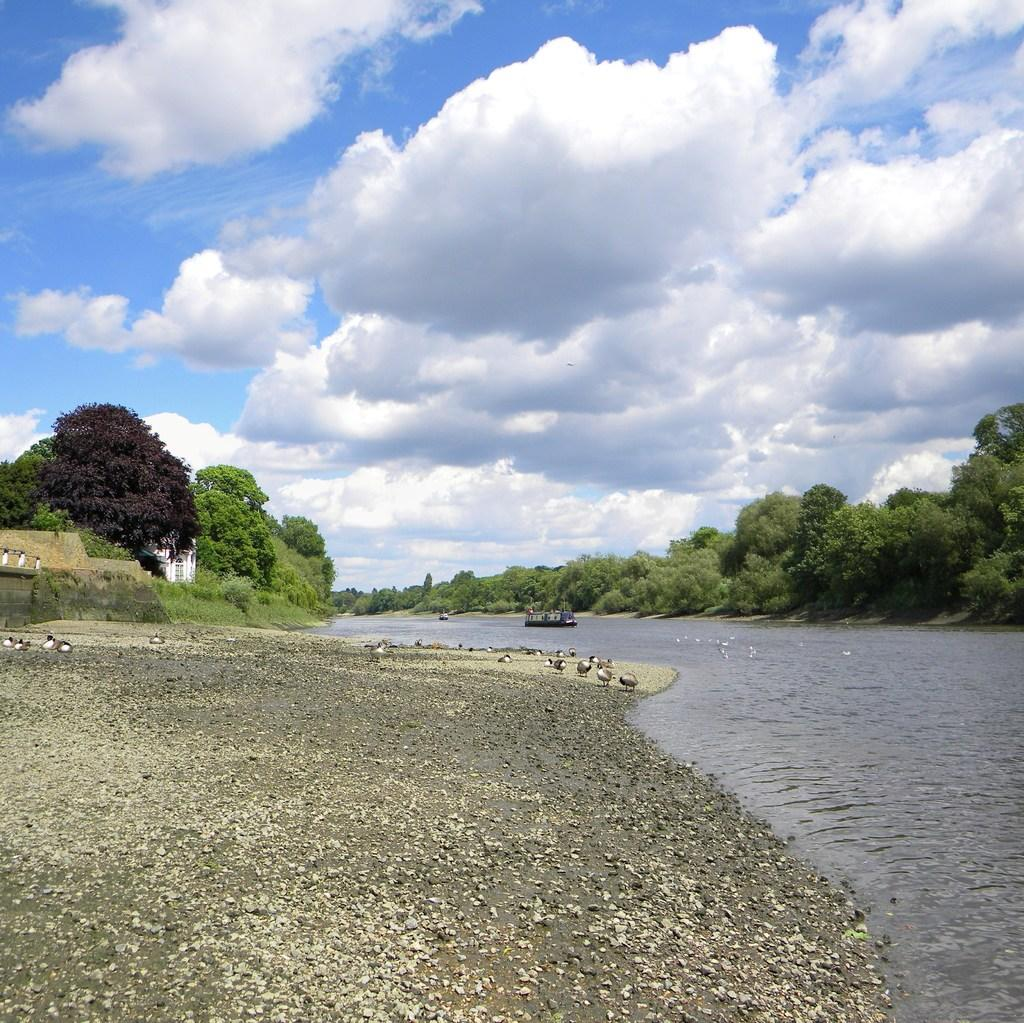What type of vegetation can be seen in the image? There are trees in the image. What is located in the water in the image? There is a boat in the water in the image. What animals are on the ground in the image? There are ducks on the ground in the image. What type of structure is present in the image? There is a house in the image. How would you describe the sky in the image? The sky is blue and cloudy in the image. What type of ground surface is visible in the image? There are stones on the ground in the image. How many minutes does it take for the quince to ripen in the image? There is no quince present in the image, so it is not possible to determine how long it would take to ripen. Is there a bike visible in the image? No, there is no bike present in the image. 